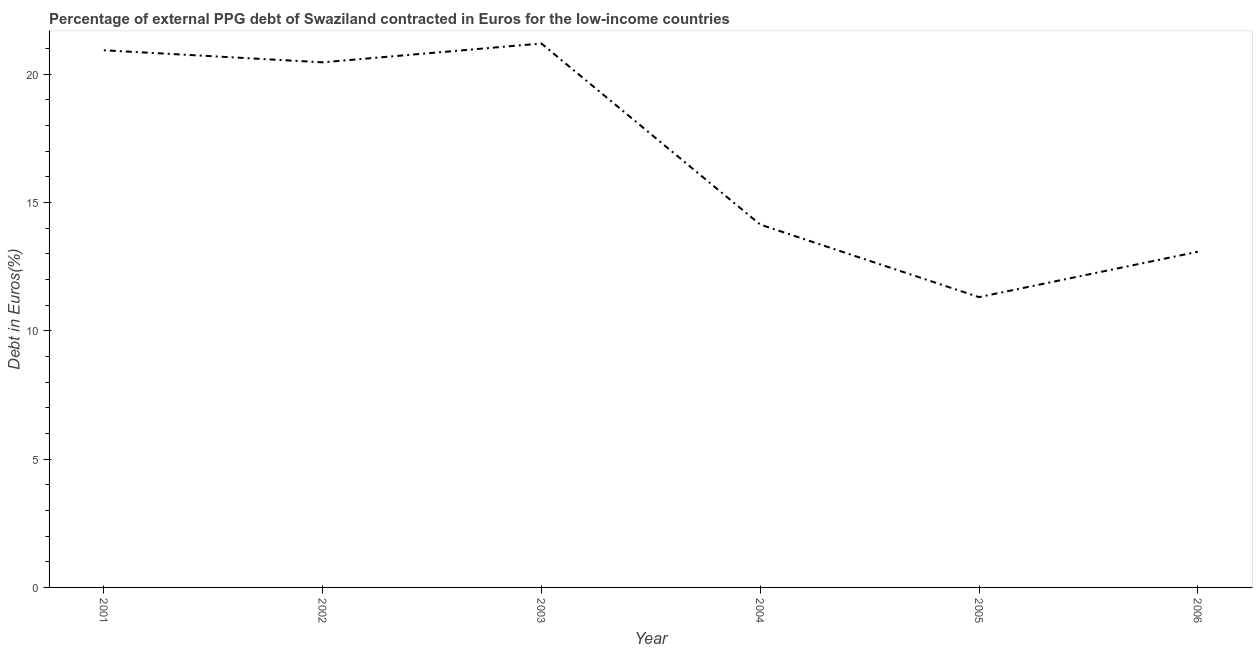What is the currency composition of ppg debt in 2001?
Offer a very short reply. 20.94. Across all years, what is the maximum currency composition of ppg debt?
Your answer should be compact. 21.2. Across all years, what is the minimum currency composition of ppg debt?
Your answer should be very brief. 11.31. In which year was the currency composition of ppg debt maximum?
Ensure brevity in your answer.  2003. In which year was the currency composition of ppg debt minimum?
Keep it short and to the point. 2005. What is the sum of the currency composition of ppg debt?
Keep it short and to the point. 101.14. What is the difference between the currency composition of ppg debt in 2005 and 2006?
Provide a short and direct response. -1.77. What is the average currency composition of ppg debt per year?
Provide a short and direct response. 16.86. What is the median currency composition of ppg debt?
Give a very brief answer. 17.3. In how many years, is the currency composition of ppg debt greater than 1 %?
Ensure brevity in your answer.  6. Do a majority of the years between 2006 and 2003 (inclusive) have currency composition of ppg debt greater than 5 %?
Make the answer very short. Yes. What is the ratio of the currency composition of ppg debt in 2003 to that in 2004?
Give a very brief answer. 1.5. Is the currency composition of ppg debt in 2001 less than that in 2002?
Keep it short and to the point. No. What is the difference between the highest and the second highest currency composition of ppg debt?
Keep it short and to the point. 0.26. What is the difference between the highest and the lowest currency composition of ppg debt?
Provide a short and direct response. 9.88. Does the currency composition of ppg debt monotonically increase over the years?
Make the answer very short. No. How many lines are there?
Your answer should be compact. 1. What is the difference between two consecutive major ticks on the Y-axis?
Keep it short and to the point. 5. Does the graph contain any zero values?
Your response must be concise. No. What is the title of the graph?
Your answer should be compact. Percentage of external PPG debt of Swaziland contracted in Euros for the low-income countries. What is the label or title of the X-axis?
Provide a succinct answer. Year. What is the label or title of the Y-axis?
Your answer should be very brief. Debt in Euros(%). What is the Debt in Euros(%) of 2001?
Give a very brief answer. 20.94. What is the Debt in Euros(%) of 2002?
Your answer should be compact. 20.47. What is the Debt in Euros(%) in 2003?
Provide a short and direct response. 21.2. What is the Debt in Euros(%) in 2004?
Provide a short and direct response. 14.14. What is the Debt in Euros(%) in 2005?
Provide a short and direct response. 11.31. What is the Debt in Euros(%) of 2006?
Give a very brief answer. 13.08. What is the difference between the Debt in Euros(%) in 2001 and 2002?
Provide a succinct answer. 0.47. What is the difference between the Debt in Euros(%) in 2001 and 2003?
Your answer should be compact. -0.26. What is the difference between the Debt in Euros(%) in 2001 and 2004?
Offer a terse response. 6.79. What is the difference between the Debt in Euros(%) in 2001 and 2005?
Your answer should be very brief. 9.62. What is the difference between the Debt in Euros(%) in 2001 and 2006?
Ensure brevity in your answer.  7.85. What is the difference between the Debt in Euros(%) in 2002 and 2003?
Your answer should be compact. -0.73. What is the difference between the Debt in Euros(%) in 2002 and 2004?
Make the answer very short. 6.32. What is the difference between the Debt in Euros(%) in 2002 and 2005?
Keep it short and to the point. 9.15. What is the difference between the Debt in Euros(%) in 2002 and 2006?
Provide a succinct answer. 7.38. What is the difference between the Debt in Euros(%) in 2003 and 2004?
Keep it short and to the point. 7.06. What is the difference between the Debt in Euros(%) in 2003 and 2005?
Provide a short and direct response. 9.88. What is the difference between the Debt in Euros(%) in 2003 and 2006?
Provide a succinct answer. 8.12. What is the difference between the Debt in Euros(%) in 2004 and 2005?
Make the answer very short. 2.83. What is the difference between the Debt in Euros(%) in 2004 and 2006?
Your response must be concise. 1.06. What is the difference between the Debt in Euros(%) in 2005 and 2006?
Ensure brevity in your answer.  -1.77. What is the ratio of the Debt in Euros(%) in 2001 to that in 2004?
Keep it short and to the point. 1.48. What is the ratio of the Debt in Euros(%) in 2001 to that in 2005?
Offer a very short reply. 1.85. What is the ratio of the Debt in Euros(%) in 2001 to that in 2006?
Ensure brevity in your answer.  1.6. What is the ratio of the Debt in Euros(%) in 2002 to that in 2003?
Keep it short and to the point. 0.96. What is the ratio of the Debt in Euros(%) in 2002 to that in 2004?
Give a very brief answer. 1.45. What is the ratio of the Debt in Euros(%) in 2002 to that in 2005?
Keep it short and to the point. 1.81. What is the ratio of the Debt in Euros(%) in 2002 to that in 2006?
Keep it short and to the point. 1.56. What is the ratio of the Debt in Euros(%) in 2003 to that in 2004?
Your answer should be compact. 1.5. What is the ratio of the Debt in Euros(%) in 2003 to that in 2005?
Your answer should be compact. 1.87. What is the ratio of the Debt in Euros(%) in 2003 to that in 2006?
Your answer should be compact. 1.62. What is the ratio of the Debt in Euros(%) in 2004 to that in 2006?
Provide a succinct answer. 1.08. What is the ratio of the Debt in Euros(%) in 2005 to that in 2006?
Ensure brevity in your answer.  0.86. 